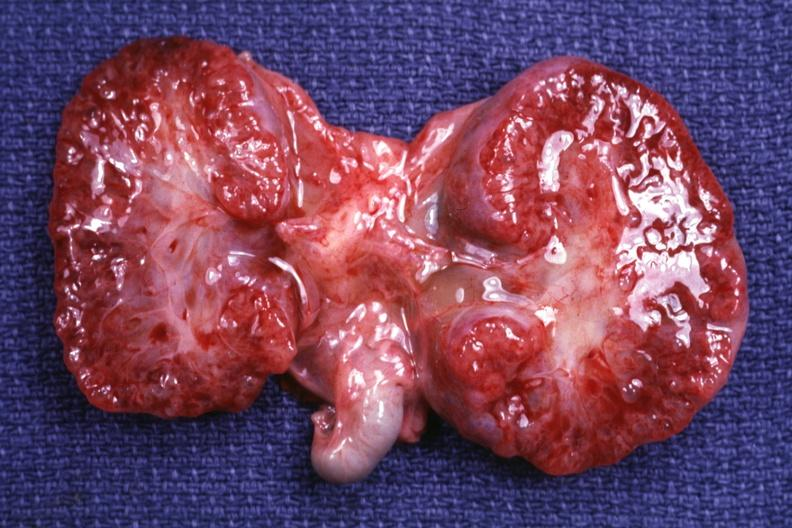does papilloma on vocal cord show cut surface both kidneys?
Answer the question using a single word or phrase. No 